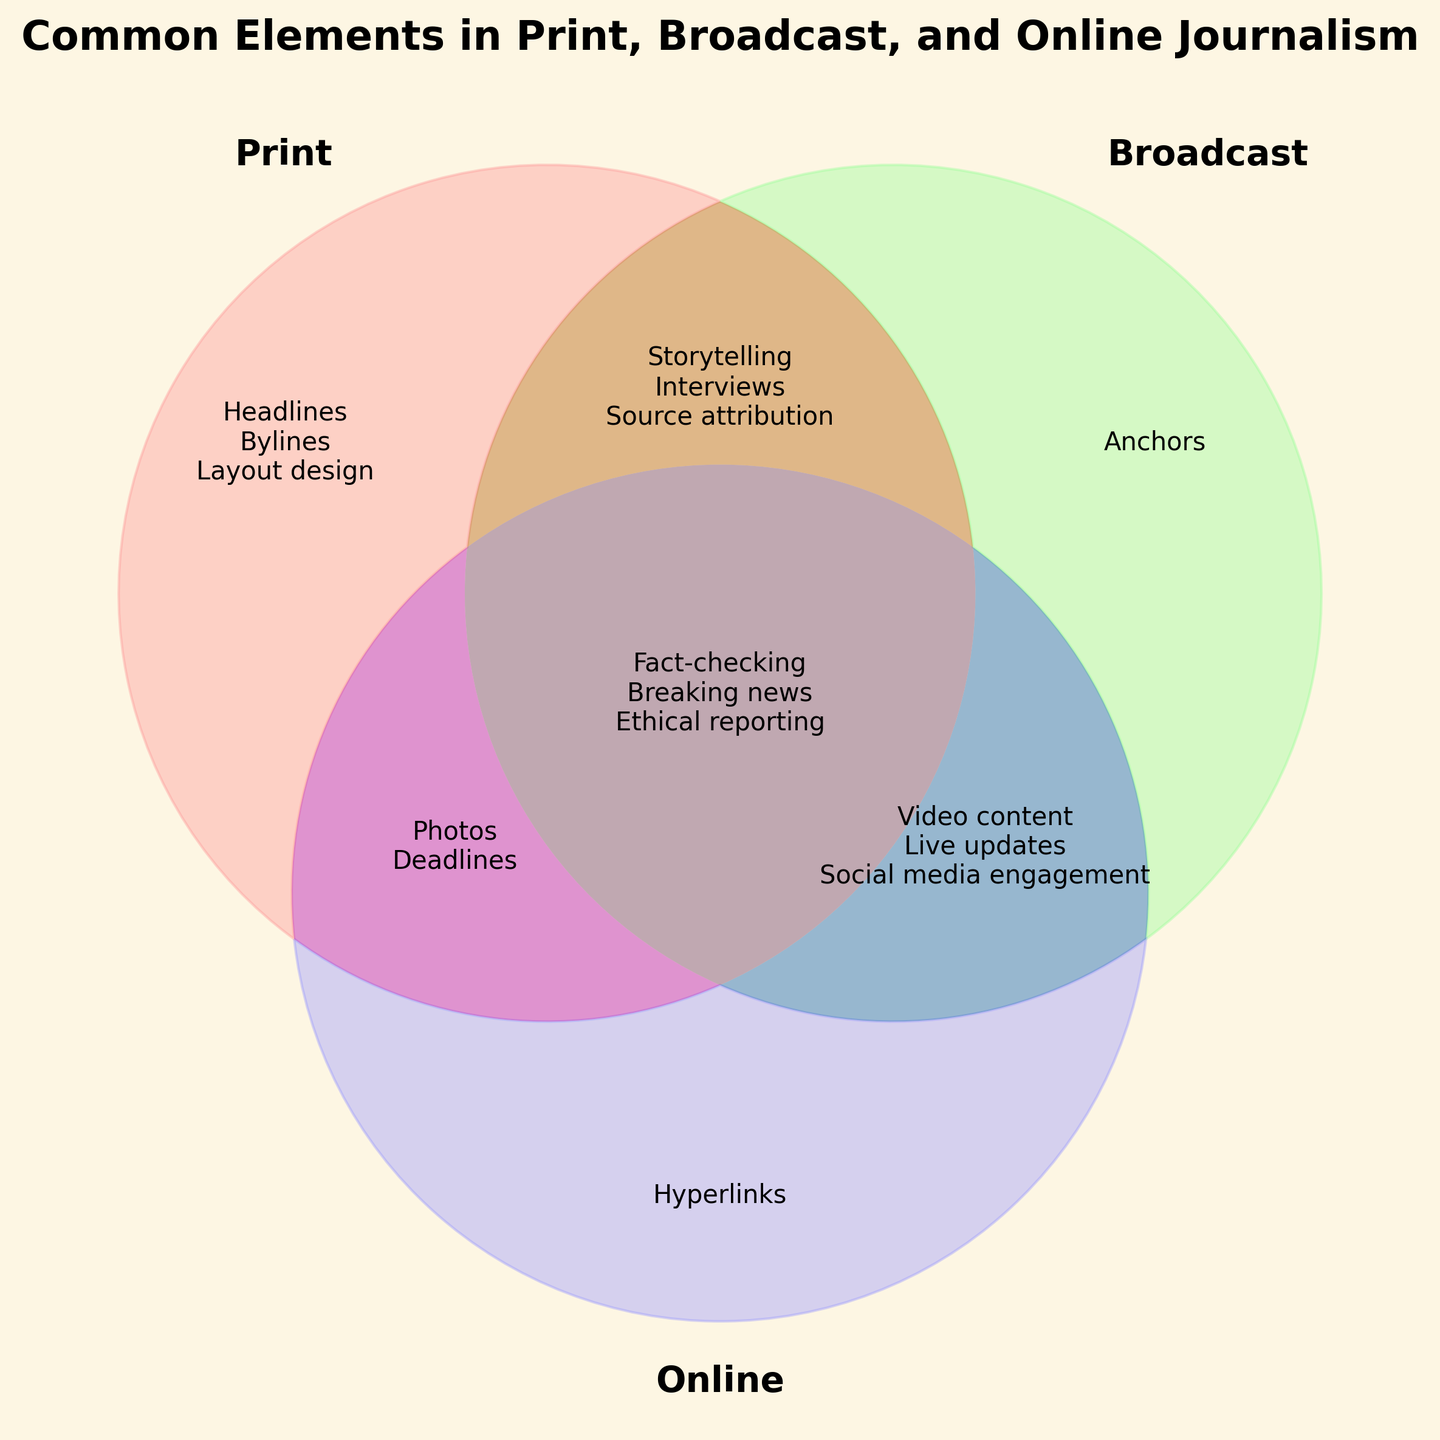What's the title of the Venn Diagram? The title is found at the top of the figure, which provides an overview of the Venn Diagram's purpose.
Answer: Common Elements in Print, Broadcast, and Online Journalism Which elements are unique to Print journalism? Look at the section labeled “100” in the Venn Diagram, which represents elements found only in Print journalism.
Answer: Headlines, Bylines, Layout design What elements are common between Print and Broadcast journalism? Check the section labeled "110" in the Venn Diagram to find elements shared by both Print and Broadcast journalism.
Answer: Storytelling How many elements are shared by all three types of journalism? Examine the section labeled "111" in the Venn Diagram, which contains elements common to Print, Broadcast, and Online journalism.
Answer: 4 Which type of journalism includes social media engagement? Identify the section that contains “Social media engagement” in the Venn Diagram. This falls under "011", meaning it's shared between Broadcast and Online journalism.
Answer: Broadcast and Online What is the overlap between Broadcast and Online journalism? Look at the section labeled "011" to find elements common to both Broadcast and Online journalism.
Answer: Video content, Live updates, Social media engagement Which category contains the unique elements of Online journalism? Find the section labeled "001" in the Venn Diagram, which includes elements only found in Online journalism.
Answer: Hyperlinks Which sections include ethical reporting? Look at the section labeled "111" which includes elements common to Print, Broadcast, and Online journalism.
Answer: All sections 